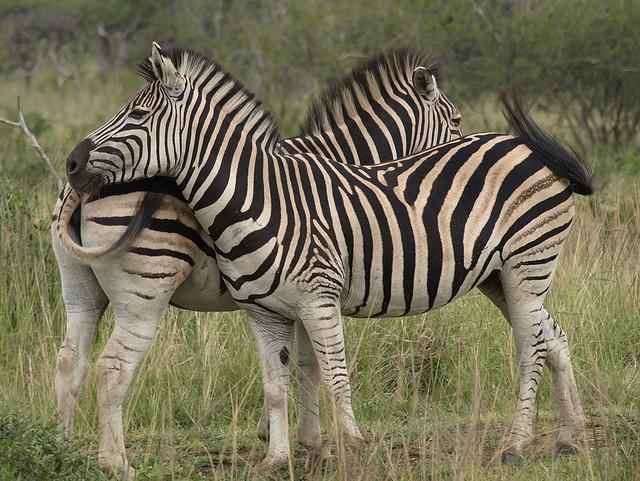How many animals are in this picture?
Give a very brief answer. 2. How many zebra legs are in this scene?
Give a very brief answer. 8. How many zebras are there?
Give a very brief answer. 2. 